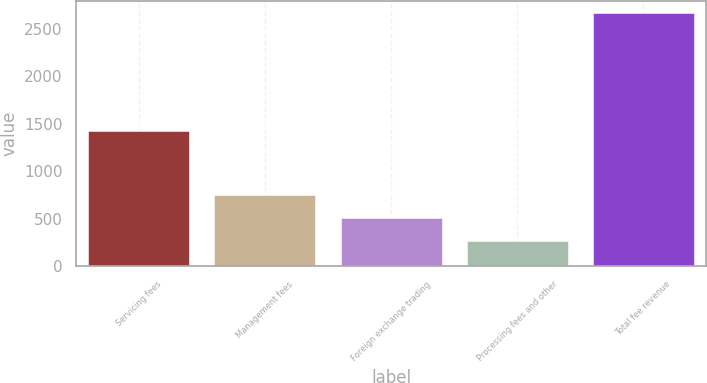<chart> <loc_0><loc_0><loc_500><loc_500><bar_chart><fcel>Servicing fees<fcel>Management fees<fcel>Foreign exchange trading<fcel>Processing fees and other<fcel>Total fee revenue<nl><fcel>1425<fcel>750.6<fcel>511.3<fcel>272<fcel>2665<nl></chart> 